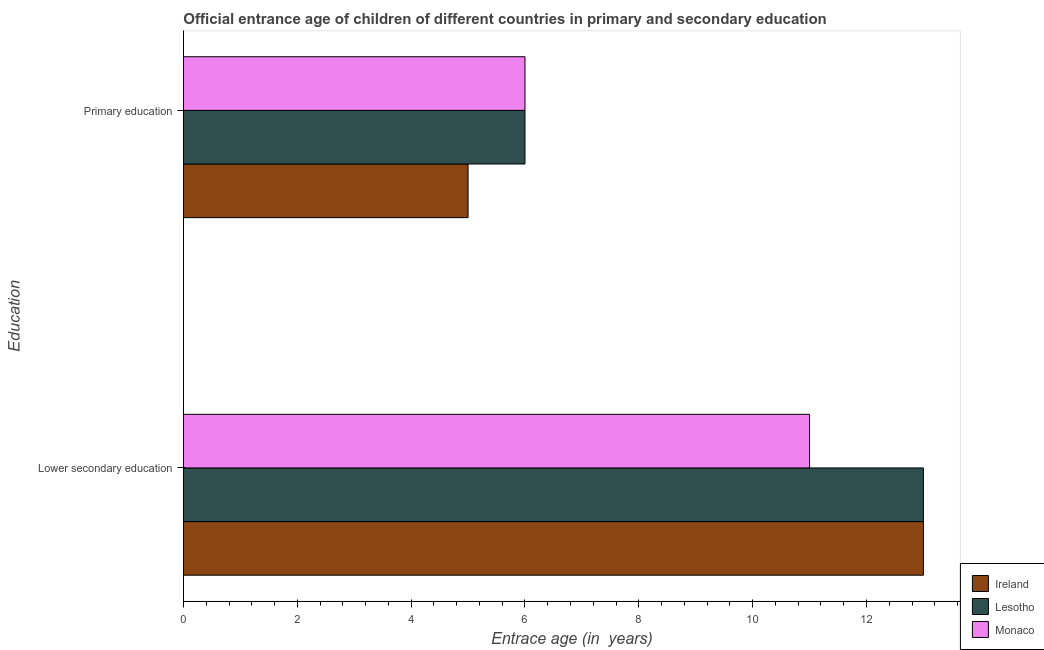How many different coloured bars are there?
Keep it short and to the point. 3. How many groups of bars are there?
Your answer should be very brief. 2. Are the number of bars on each tick of the Y-axis equal?
Your answer should be compact. Yes. How many bars are there on the 2nd tick from the top?
Your response must be concise. 3. How many bars are there on the 1st tick from the bottom?
Keep it short and to the point. 3. What is the label of the 2nd group of bars from the top?
Make the answer very short. Lower secondary education. What is the entrance age of children in lower secondary education in Ireland?
Make the answer very short. 13. Across all countries, what is the minimum entrance age of chiildren in primary education?
Offer a very short reply. 5. In which country was the entrance age of chiildren in primary education maximum?
Offer a terse response. Lesotho. In which country was the entrance age of children in lower secondary education minimum?
Provide a short and direct response. Monaco. What is the total entrance age of chiildren in primary education in the graph?
Keep it short and to the point. 17. What is the difference between the entrance age of children in lower secondary education in Ireland and that in Monaco?
Offer a very short reply. 2. What is the difference between the entrance age of chiildren in primary education in Lesotho and the entrance age of children in lower secondary education in Monaco?
Your answer should be very brief. -5. What is the average entrance age of chiildren in primary education per country?
Give a very brief answer. 5.67. What is the difference between the entrance age of chiildren in primary education and entrance age of children in lower secondary education in Lesotho?
Ensure brevity in your answer.  -7. Is the entrance age of chiildren in primary education in Lesotho less than that in Monaco?
Give a very brief answer. No. What does the 3rd bar from the top in Primary education represents?
Ensure brevity in your answer.  Ireland. What does the 2nd bar from the bottom in Primary education represents?
Provide a short and direct response. Lesotho. What is the difference between two consecutive major ticks on the X-axis?
Offer a very short reply. 2. Are the values on the major ticks of X-axis written in scientific E-notation?
Offer a very short reply. No. Does the graph contain any zero values?
Your answer should be compact. No. What is the title of the graph?
Make the answer very short. Official entrance age of children of different countries in primary and secondary education. What is the label or title of the X-axis?
Your response must be concise. Entrace age (in  years). What is the label or title of the Y-axis?
Provide a short and direct response. Education. What is the Entrace age (in  years) in Ireland in Primary education?
Ensure brevity in your answer.  5. What is the Entrace age (in  years) of Lesotho in Primary education?
Offer a very short reply. 6. What is the Entrace age (in  years) of Monaco in Primary education?
Your response must be concise. 6. Across all Education, what is the minimum Entrace age (in  years) in Lesotho?
Make the answer very short. 6. What is the total Entrace age (in  years) in Lesotho in the graph?
Provide a succinct answer. 19. What is the difference between the Entrace age (in  years) of Monaco in Lower secondary education and that in Primary education?
Provide a short and direct response. 5. What is the difference between the Entrace age (in  years) of Ireland and Entrace age (in  years) of Monaco in Lower secondary education?
Provide a short and direct response. 2. What is the difference between the Entrace age (in  years) in Lesotho and Entrace age (in  years) in Monaco in Lower secondary education?
Provide a succinct answer. 2. What is the difference between the Entrace age (in  years) in Ireland and Entrace age (in  years) in Lesotho in Primary education?
Provide a short and direct response. -1. What is the difference between the Entrace age (in  years) in Ireland and Entrace age (in  years) in Monaco in Primary education?
Make the answer very short. -1. What is the ratio of the Entrace age (in  years) in Lesotho in Lower secondary education to that in Primary education?
Keep it short and to the point. 2.17. What is the ratio of the Entrace age (in  years) of Monaco in Lower secondary education to that in Primary education?
Make the answer very short. 1.83. What is the difference between the highest and the second highest Entrace age (in  years) in Ireland?
Offer a very short reply. 8. 